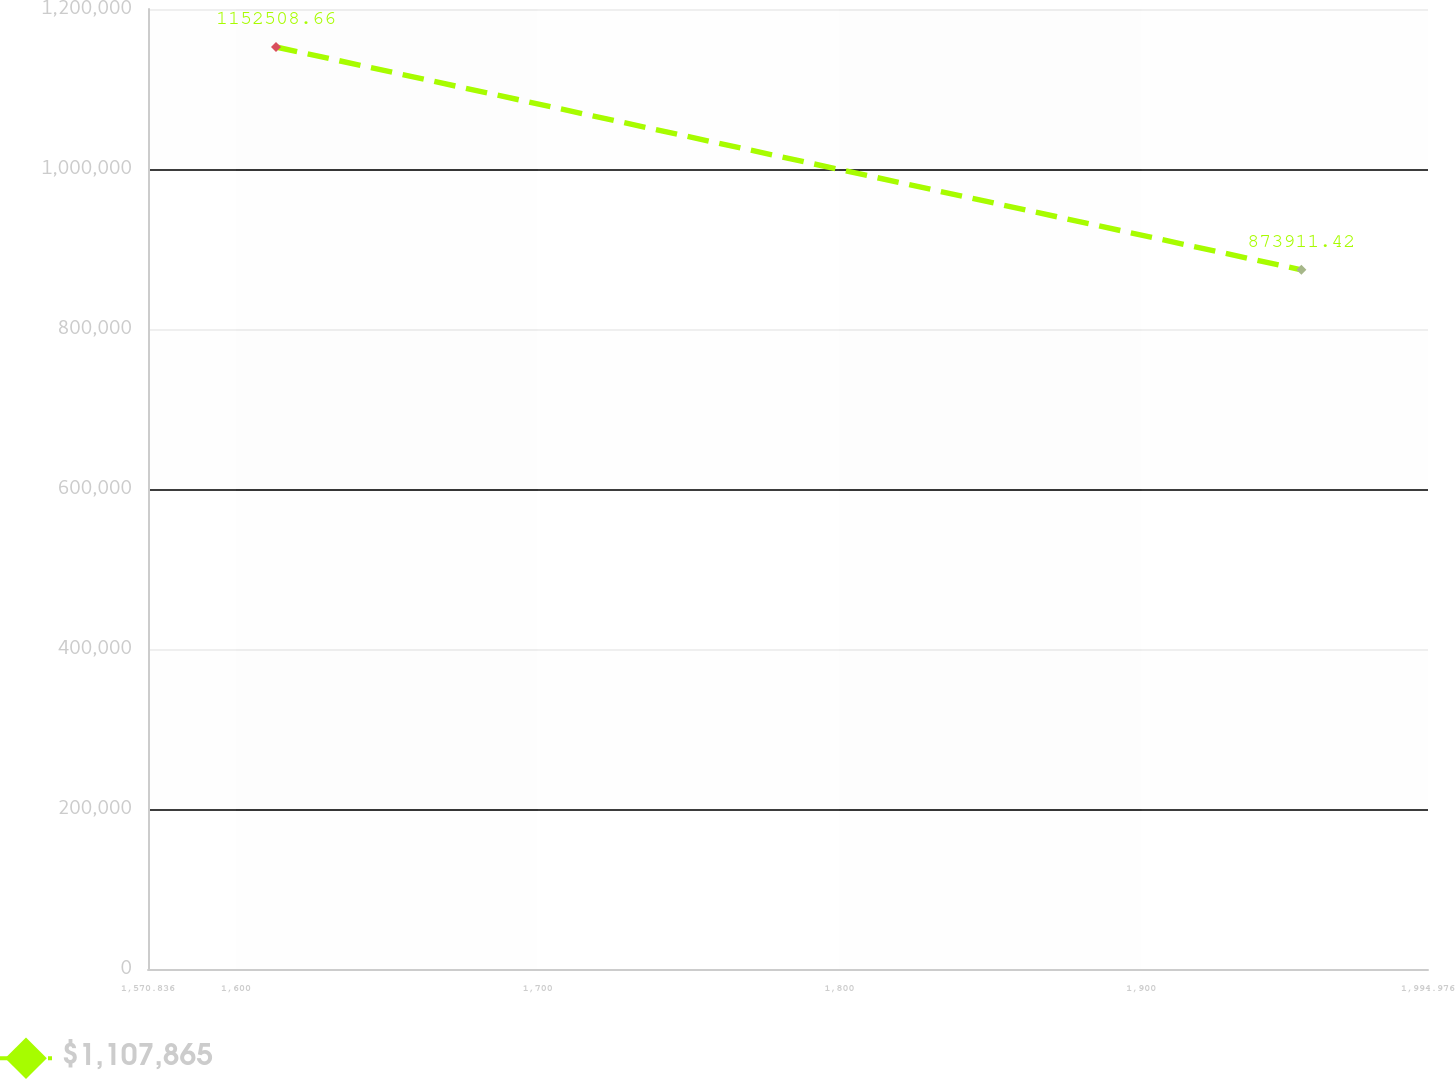Convert chart. <chart><loc_0><loc_0><loc_500><loc_500><line_chart><ecel><fcel>$1,107,865<nl><fcel>1613.25<fcel>1.15251e+06<nl><fcel>1953.01<fcel>873911<nl><fcel>1995.2<fcel>804115<nl><fcel>2037.39<fcel>765405<nl></chart> 